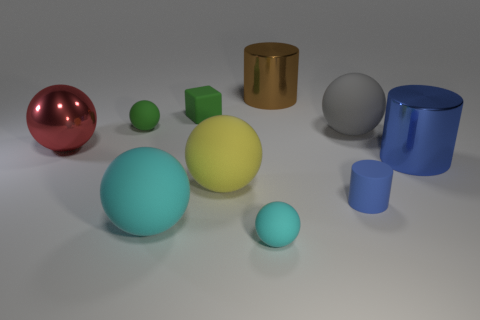Are there any other cylinders of the same color as the rubber cylinder?
Give a very brief answer. Yes. There is a object that is the same color as the matte cube; what material is it?
Ensure brevity in your answer.  Rubber. Does the tiny cube have the same color as the small thing that is left of the green matte block?
Provide a succinct answer. Yes. The yellow rubber object is what size?
Give a very brief answer. Large. What is the shape of the shiny thing that is both on the right side of the large shiny sphere and in front of the small green cube?
Ensure brevity in your answer.  Cylinder. What number of gray objects are metallic cylinders or small rubber balls?
Your answer should be compact. 0. Do the green matte object that is left of the rubber cube and the shiny object in front of the red metallic sphere have the same size?
Make the answer very short. No. What number of things are either tiny gray matte objects or tiny green things?
Offer a very short reply. 2. Is there a red metal object that has the same shape as the large gray rubber object?
Provide a short and direct response. Yes. Are there fewer small green matte cubes than rubber balls?
Your answer should be compact. Yes. 